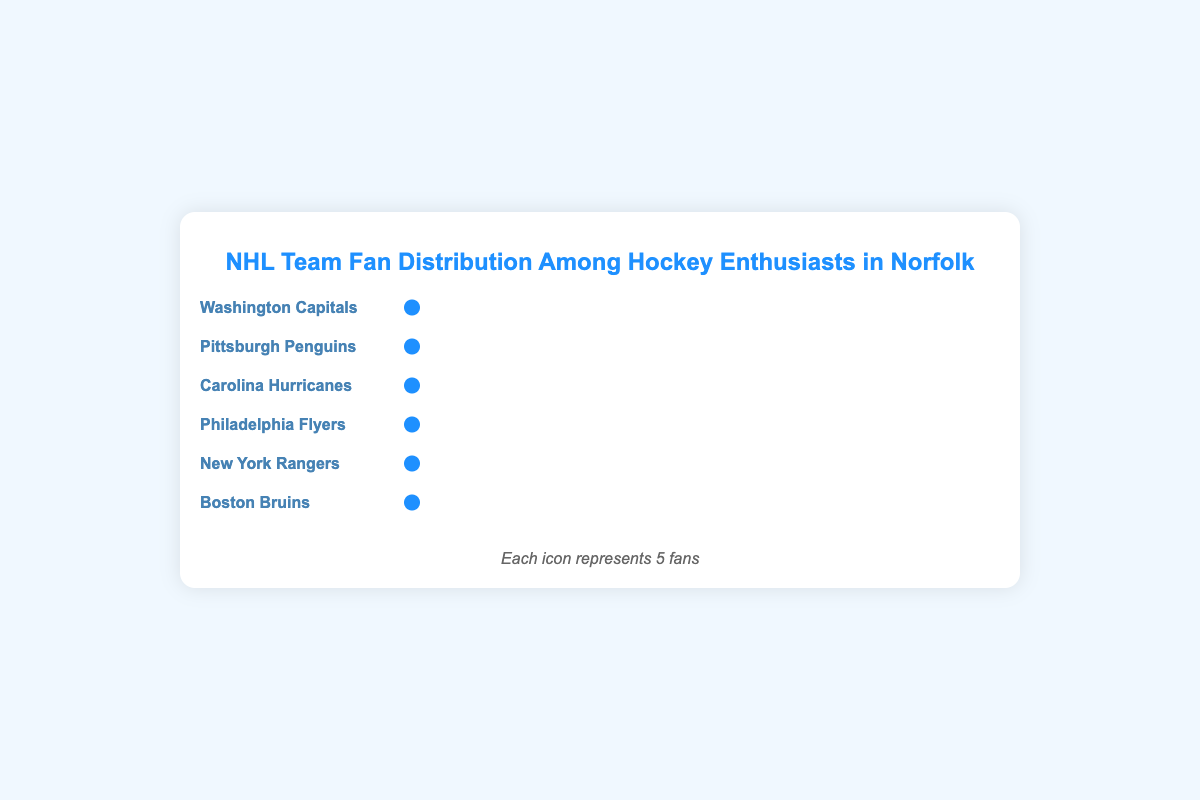How many fans do the Boston Bruins have? Each icon represents 5 fans, and the Boston Bruins have a single icon. So, multiplying 1 icon by 5 gives us the total number of fans for the Boston Bruins.
Answer: 5 Which team has the largest number of fans? By observing the width of the fan-icon sections, the Washington Capitals have the widest section, indicating the most fans among all teams.
Answer: Washington Capitals What is the total number of fans for the Washington Capitals and Pittsburgh Penguins combined? The Washington Capitals have 35 fans and the Pittsburgh Penguins have 25 fans. Adding these together gives 35 + 25 = 60.
Answer: 60 How many more fans do the Washington Capitals have compared to the New York Rangers? The Washington Capitals have 35 fans, and the New York Rangers have 10 fans. Subtracting the number of fans of the New York Rangers from the Washington Capitals gives 35 - 10 = 25.
Answer: 25 Which team has fewer fans, the Philadelphia Flyers or the Boston Bruins? By comparing the number of icons, the Boston Bruins have fewer fans with just one icon (5 fans) compared to the Philadelphia Flyers' three icons (15 fans).
Answer: Boston Bruins What percentage of the total fans does the Washington Capitals' fan base represent? The Washington Capitals have 35 fans, and the total number of enthusiasts is 110. The percentage is calculated as (35 / 110) * 100 = 31.82%.
Answer: 31.82% What's the difference in the number of fans between the Carolina Hurricanes and the Philadelphia Flyers? The Carolina Hurricanes have 20 fans and the Philadelphia Flyers have 15 fans. Subtracting the Flyers' fans from the Hurricanes' gives 20 - 15 = 5.
Answer: 5 How many teams have more than 20 fans? By looking at the fan counts, the Washington Capitals have 35 fans, Pittsburgh Penguins have 25 fans, and Carolina Hurricanes have 20 fans. Only the Capitals and Penguins have more than 20 fans.
Answer: 2 teams What is the average number of fans per team? Adding the number of fans for all teams (35 + 25 + 20 + 15 + 10 + 5) gives 110 fans across 6 teams. Dividing the total fans by the number of teams gives 110 / 6 = approximately 18.33.
Answer: 18.33 